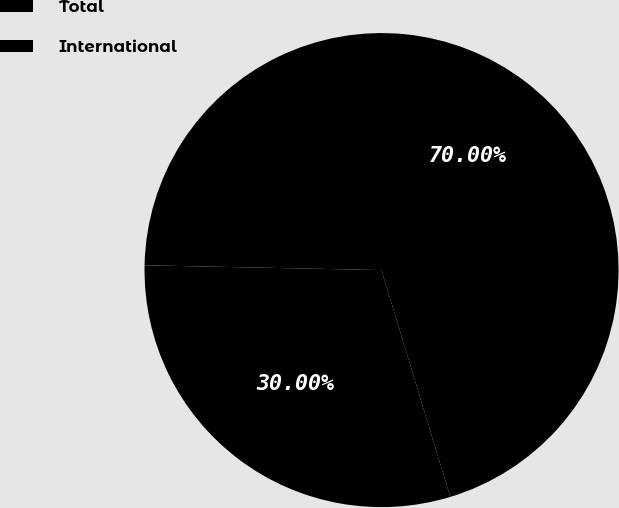Convert chart. <chart><loc_0><loc_0><loc_500><loc_500><pie_chart><fcel>Total<fcel>International<nl><fcel>30.0%<fcel>70.0%<nl></chart> 